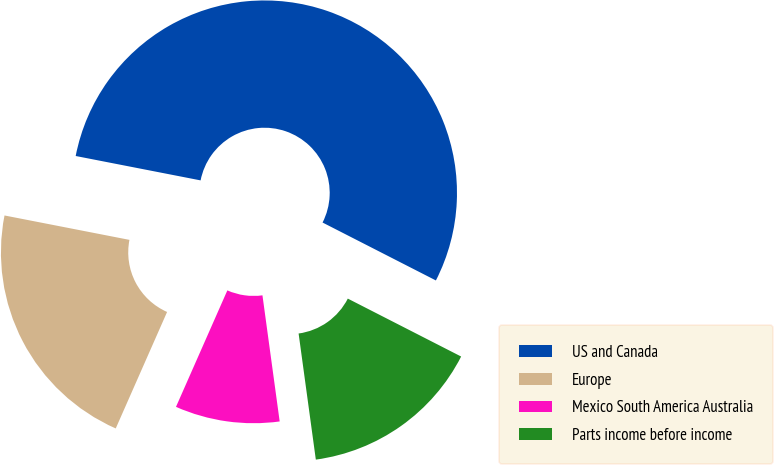Convert chart to OTSL. <chart><loc_0><loc_0><loc_500><loc_500><pie_chart><fcel>US and Canada<fcel>Europe<fcel>Mexico South America Australia<fcel>Parts income before income<nl><fcel>54.45%<fcel>21.46%<fcel>8.77%<fcel>15.32%<nl></chart> 